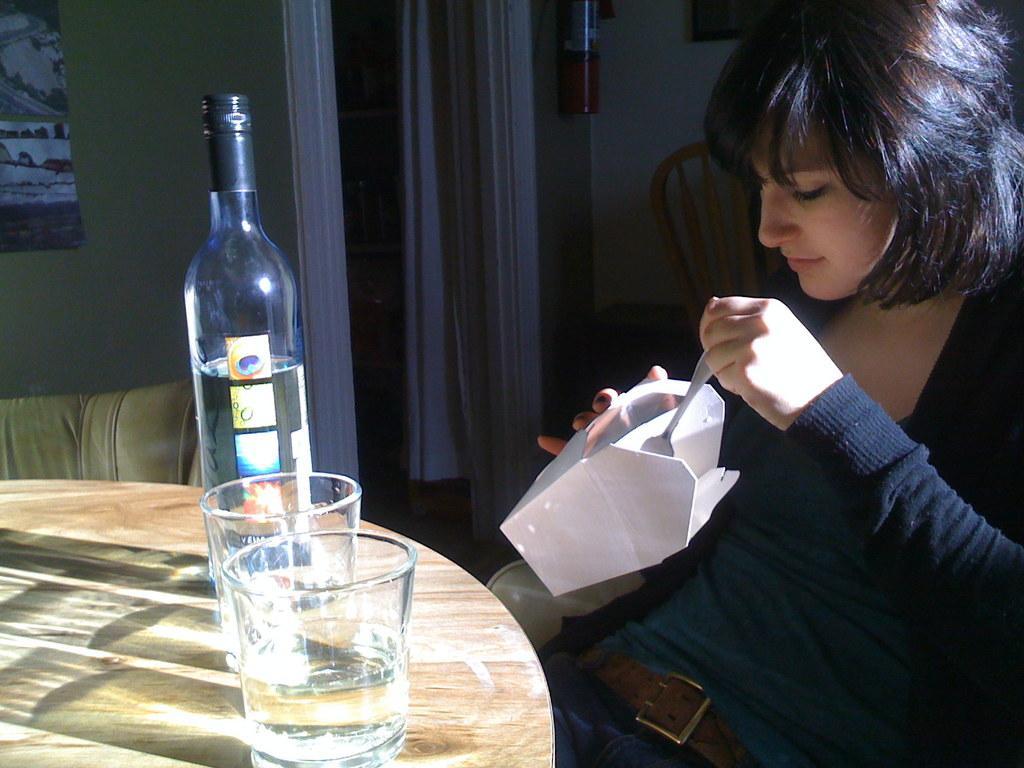Describe this image in one or two sentences. In this picture we can see woman sitting on chair and in front of them there is table and on table we can see glass, bottle and background we can see wall, frame, curtains, chair. 